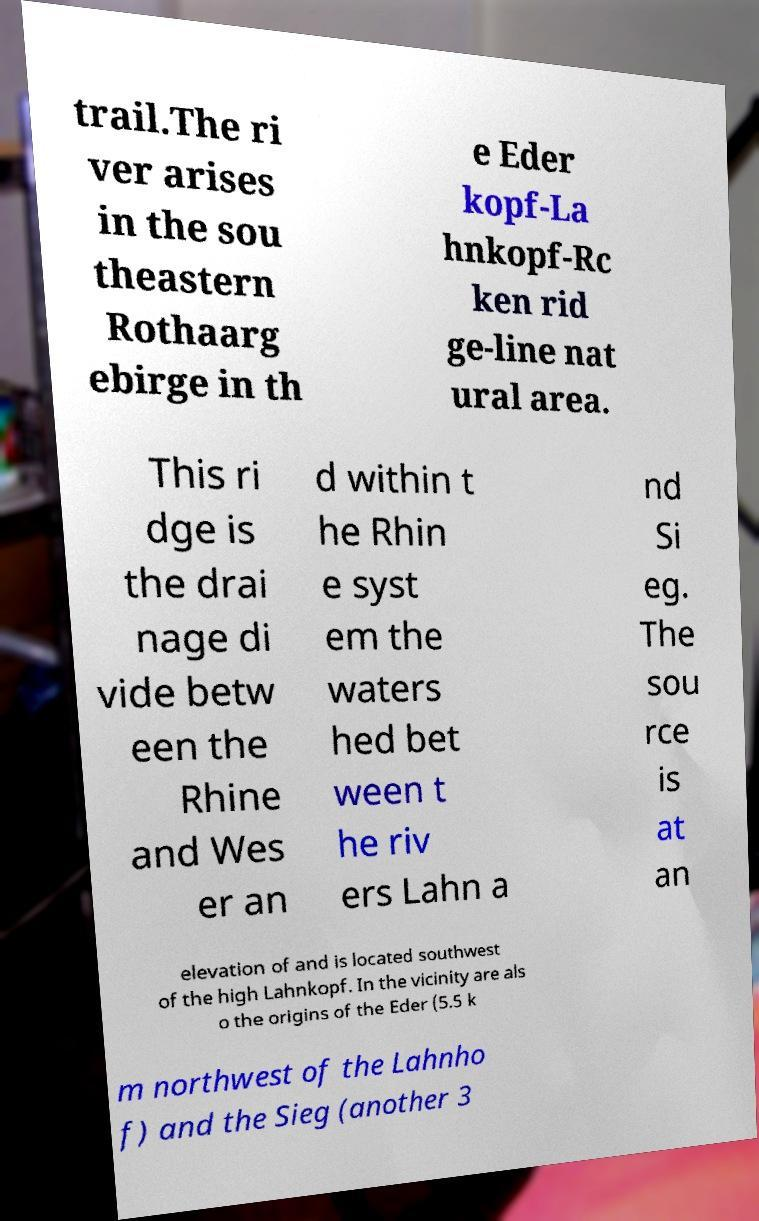Can you read and provide the text displayed in the image?This photo seems to have some interesting text. Can you extract and type it out for me? trail.The ri ver arises in the sou theastern Rothaarg ebirge in th e Eder kopf-La hnkopf-Rc ken rid ge-line nat ural area. This ri dge is the drai nage di vide betw een the Rhine and Wes er an d within t he Rhin e syst em the waters hed bet ween t he riv ers Lahn a nd Si eg. The sou rce is at an elevation of and is located southwest of the high Lahnkopf. In the vicinity are als o the origins of the Eder (5.5 k m northwest of the Lahnho f) and the Sieg (another 3 